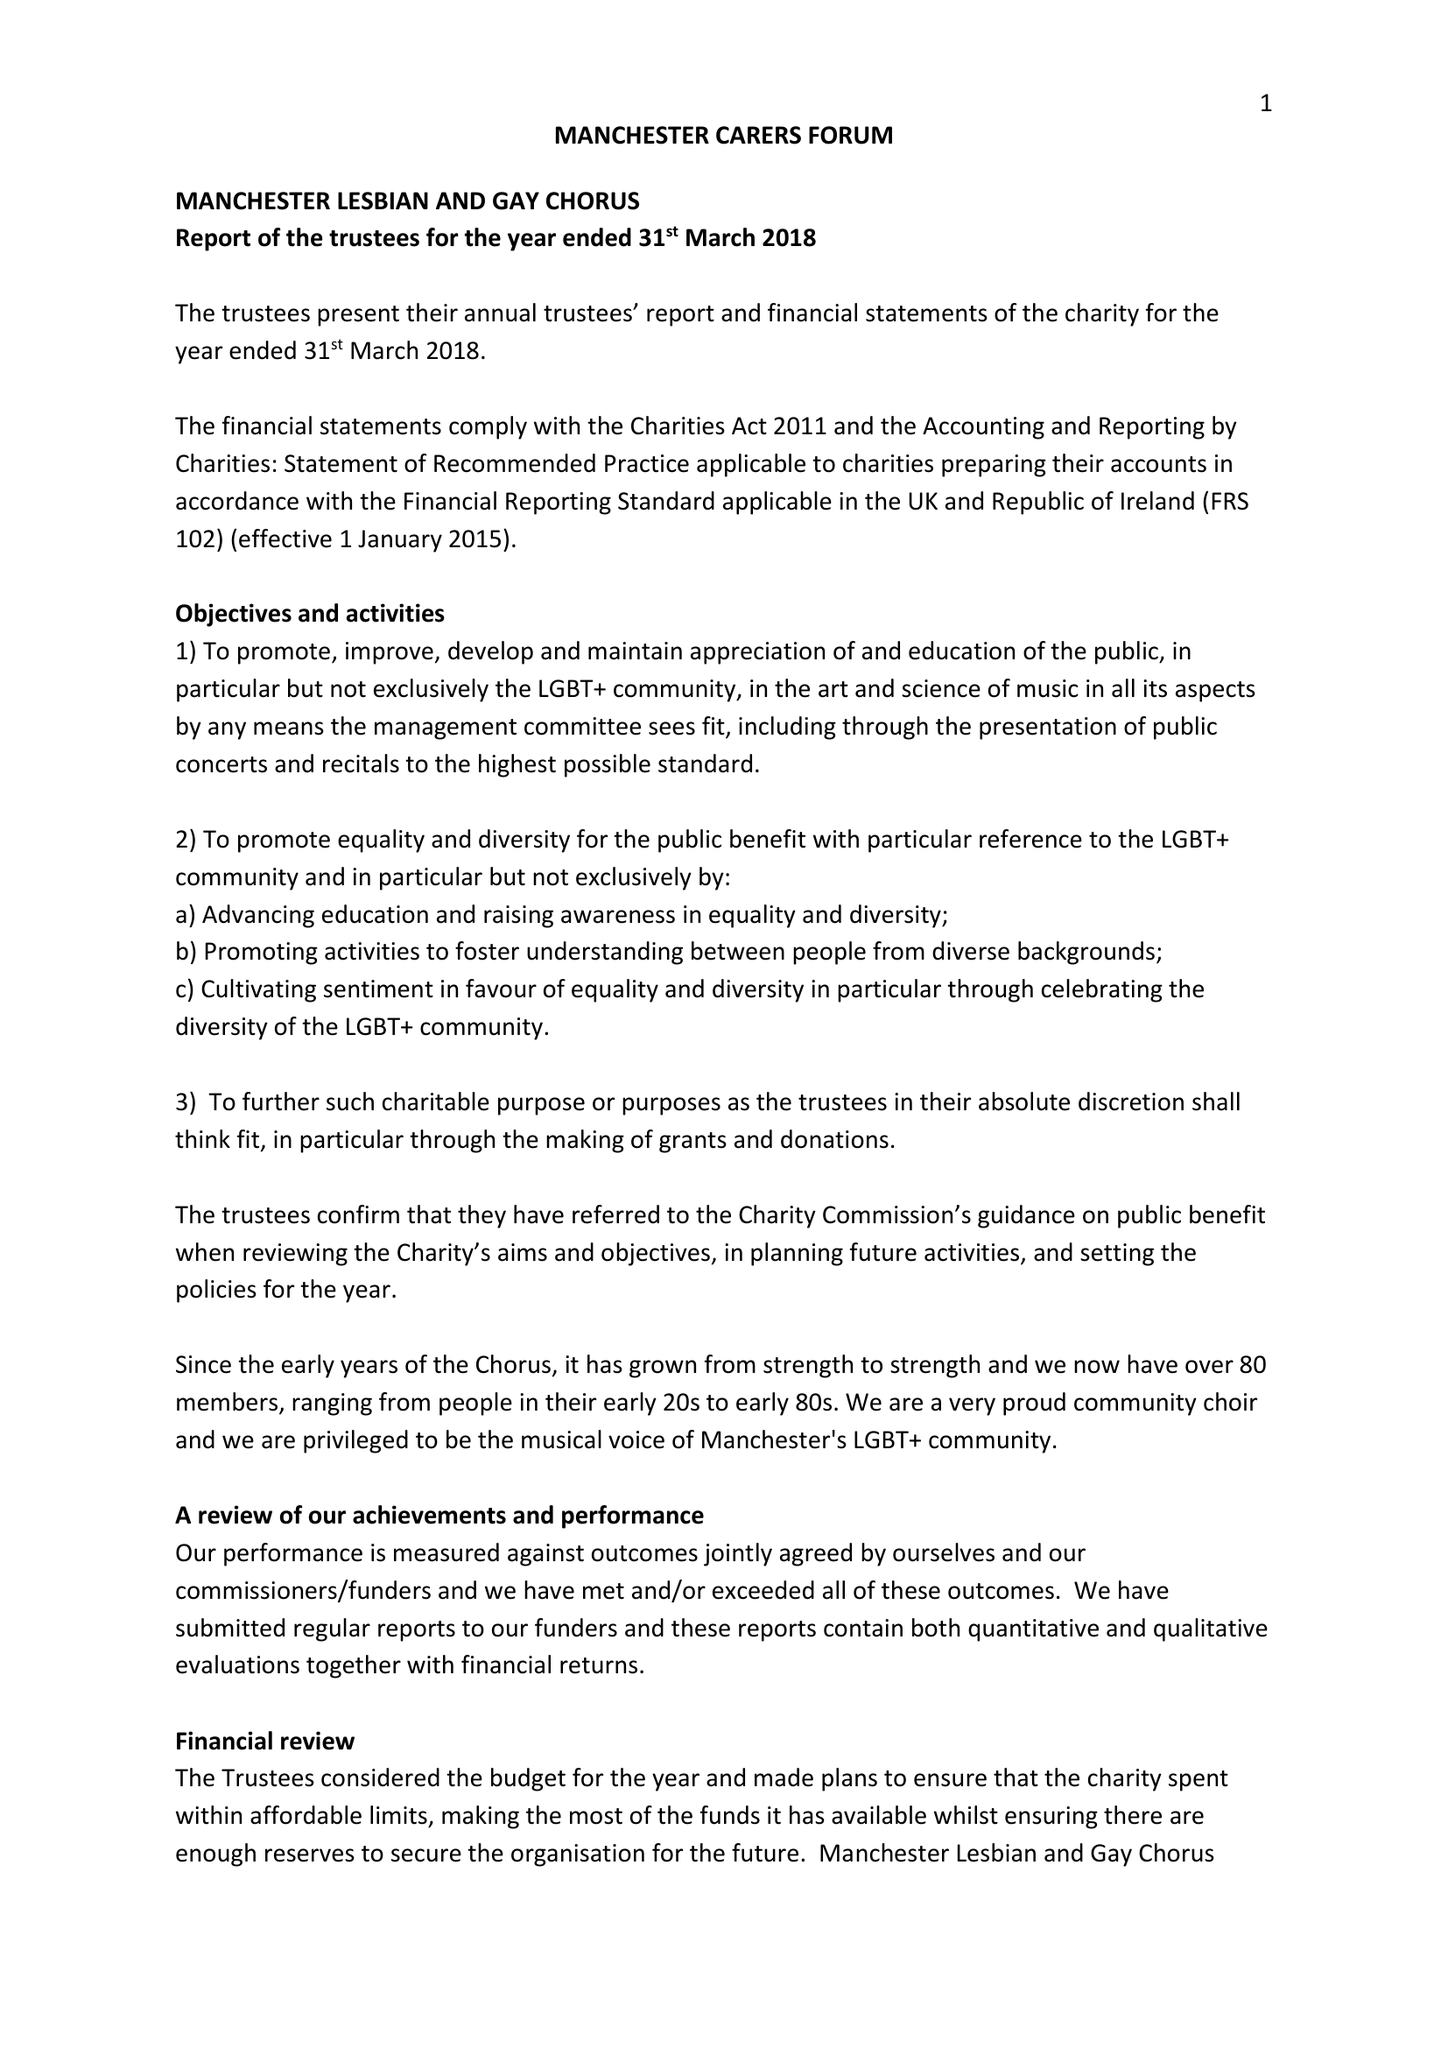What is the value for the charity_name?
Answer the question using a single word or phrase. Manchester Lesbian and Gay Chorus 